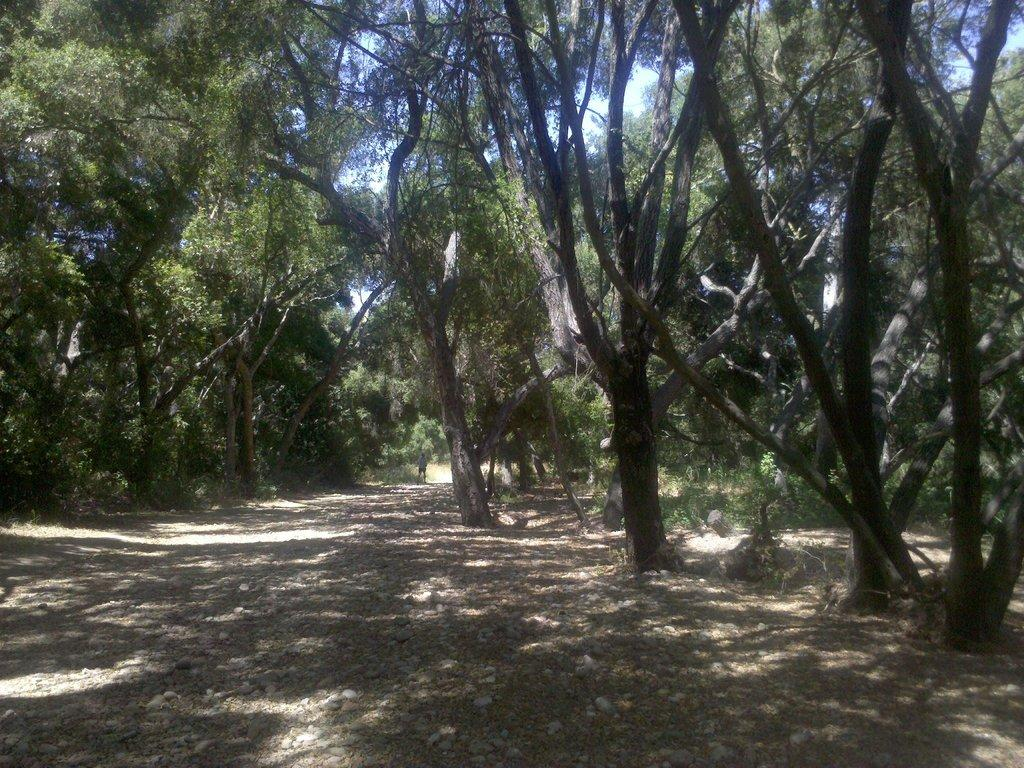What type of objects can be seen on the ground in the image? There are stones on the ground in the image. What is the person in the image doing? The person is standing on the ground in the image. What type of vegetation is visible in the image? There are trees visible in the image. What is visible in the background of the image? The sky is visible in the background of the image. What sound does the stone make when it falls in the image? There is no sound present in the image, as it is a still photograph. What is the tendency of the trees to grow in the image? The image does not provide information about the growth patterns or tendencies of the trees. 